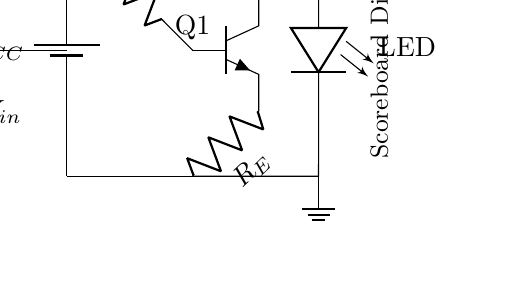What is the power supply voltage in this circuit? The power supply labeled as V_CC is the source of voltage for the circuit. It is shown in the top left corner of the diagram next to the battery symbol.
Answer: V_CC What is the role of resistor R_1 in the circuit? Resistor R_1 is connected to the base of the transistor Q1, functioning as a current-limiting resistor to control the input current to the base. Its purpose is to protect the transistor by ensuring the current does not exceed safe levels.
Answer: Current limiting What type of transistor is used in this circuit? The circuit uses an NPN transistor (labeled Q1), which is indicated by the symbol shown and is characterized by the arrangement of its terminals.
Answer: NPN How many resistors are present in the circuit? There are two resistors in the circuit, identified as R_1 and R_E, which are contributing to the functioning of the transistor and controlling the current through the LED.
Answer: Two What is the effect of the input voltage source on the circuit? The input voltage source labeled V_in is connected to the base of the transistor Q1. When the input voltage is applied, it allows current to flow into the base, turning on the transistor and enabling current flow through the LED. This means the LED will light up when the input voltage is sufficient.
Answer: Turns on the transistor What is the function of the LED in this circuit? The LED in the circuit serves as an indicator which visually represents when the circuit is active, lighting up when current flows through it, indicating that the transistor is conducting.
Answer: Indicator light What is the connection to ground in this circuit? The ground connection is made at the lower part of the circuit where the point is labeled as ground, and it serves as a reference point for all voltage levels in the circuit, establishing a common return path for current.
Answer: Common return path 